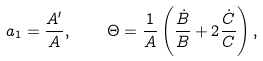Convert formula to latex. <formula><loc_0><loc_0><loc_500><loc_500>a _ { 1 } = \frac { A ^ { \prime } } { A } , \quad \Theta = \frac { 1 } { A } \left ( \frac { \dot { B } } { B } + 2 \frac { \dot { C } } { C } \right ) ,</formula> 